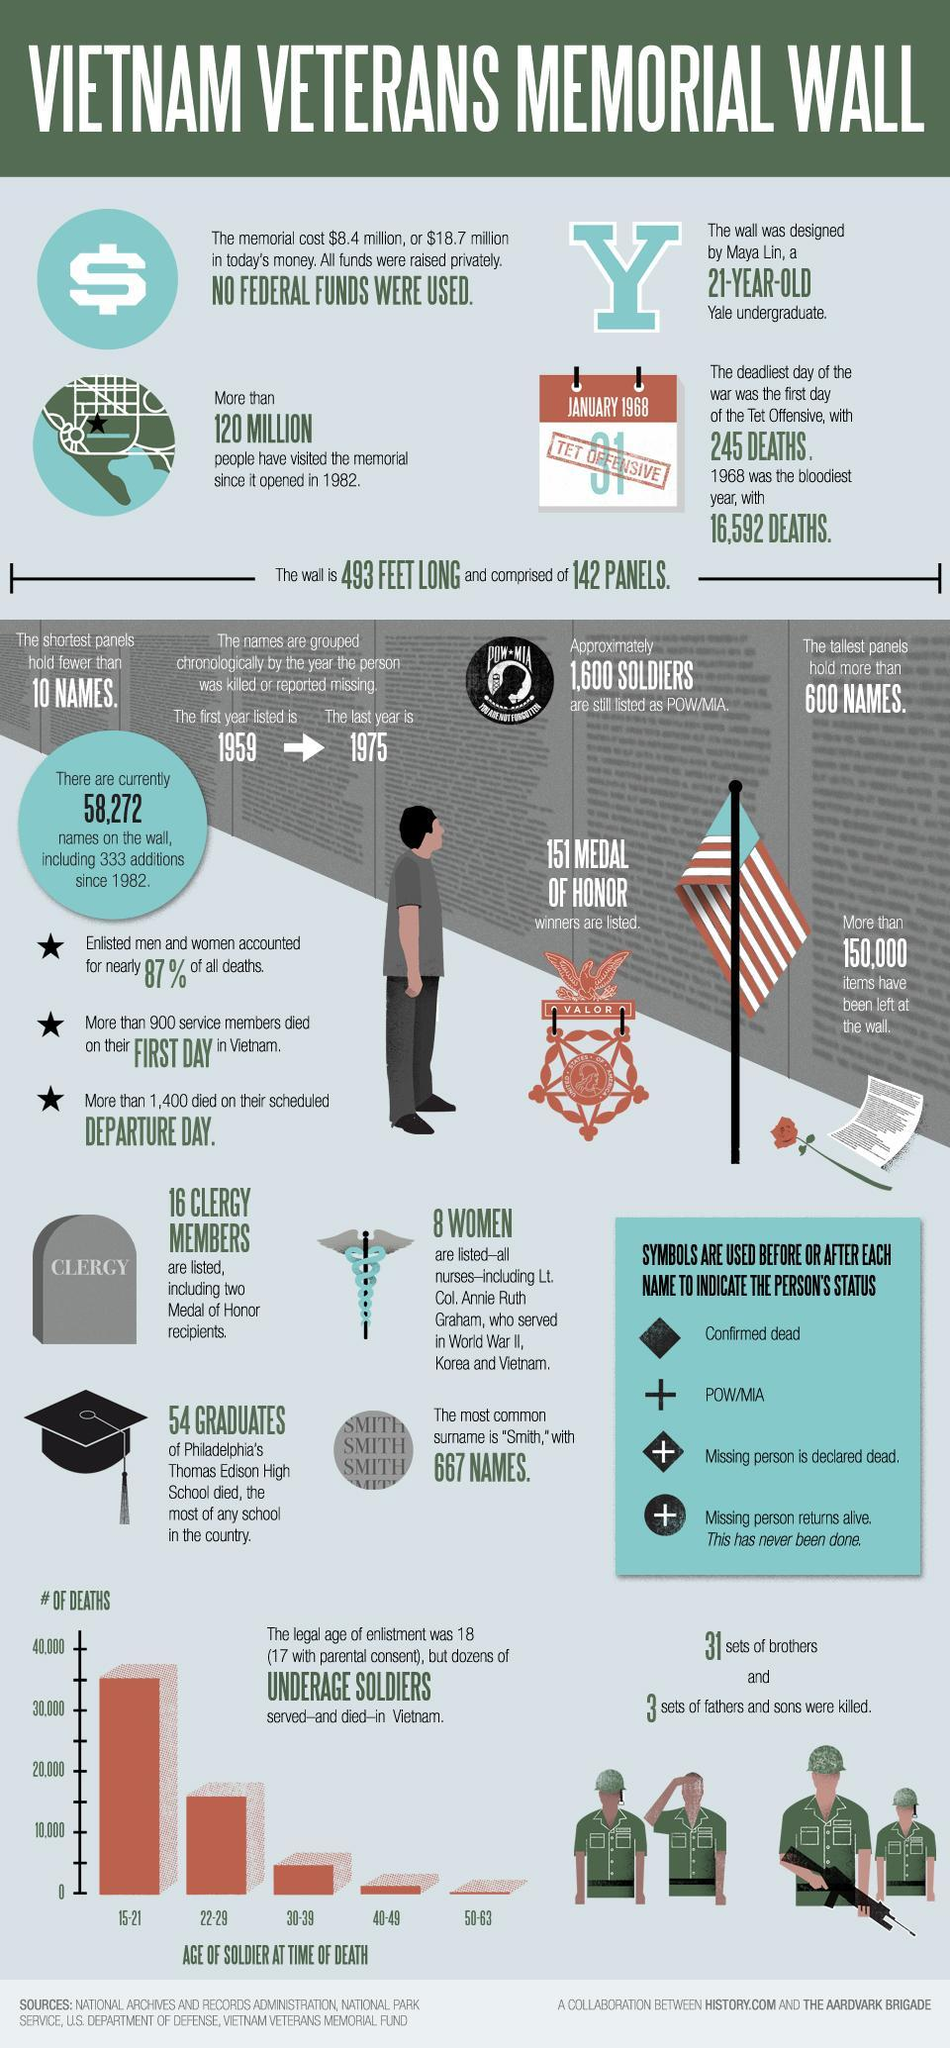what was the number of soldiers who died at the age of 15-21?
Answer the question with a short phrase. 35000 what was the number of soldiers who died at the age of 22-29? 15000 